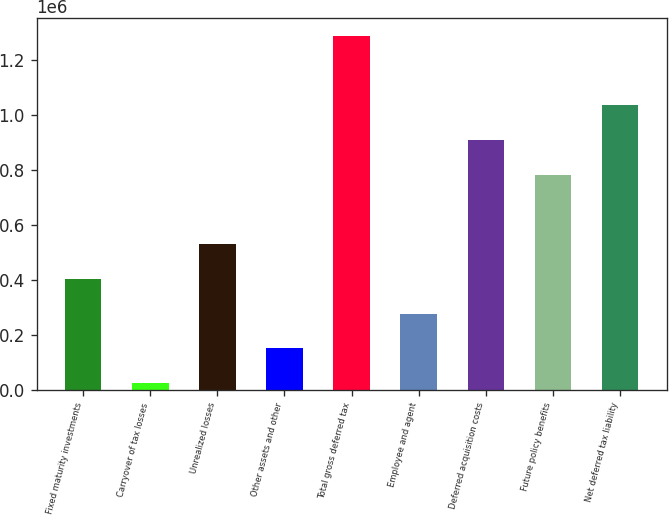Convert chart. <chart><loc_0><loc_0><loc_500><loc_500><bar_chart><fcel>Fixed maturity investments<fcel>Carryover of tax losses<fcel>Unrealized losses<fcel>Other assets and other<fcel>Total gross deferred tax<fcel>Employee and agent<fcel>Deferred acquisition costs<fcel>Future policy benefits<fcel>Net deferred tax liability<nl><fcel>403034<fcel>24541<fcel>529198<fcel>150705<fcel>1.28618e+06<fcel>276870<fcel>907691<fcel>781527<fcel>1.03386e+06<nl></chart> 